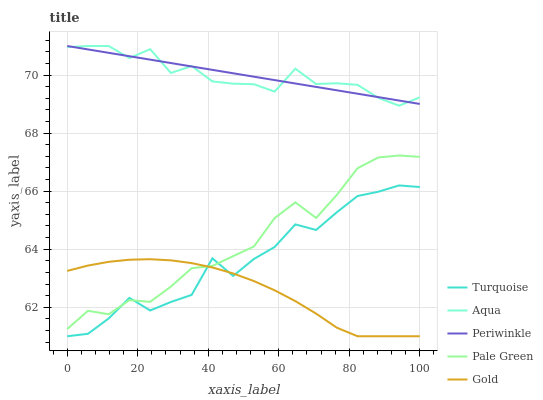Does Turquoise have the minimum area under the curve?
Answer yes or no. No. Does Turquoise have the maximum area under the curve?
Answer yes or no. No. Is Pale Green the smoothest?
Answer yes or no. No. Is Pale Green the roughest?
Answer yes or no. No. Does Pale Green have the lowest value?
Answer yes or no. No. Does Turquoise have the highest value?
Answer yes or no. No. Is Gold less than Periwinkle?
Answer yes or no. Yes. Is Aqua greater than Gold?
Answer yes or no. Yes. Does Gold intersect Periwinkle?
Answer yes or no. No. 